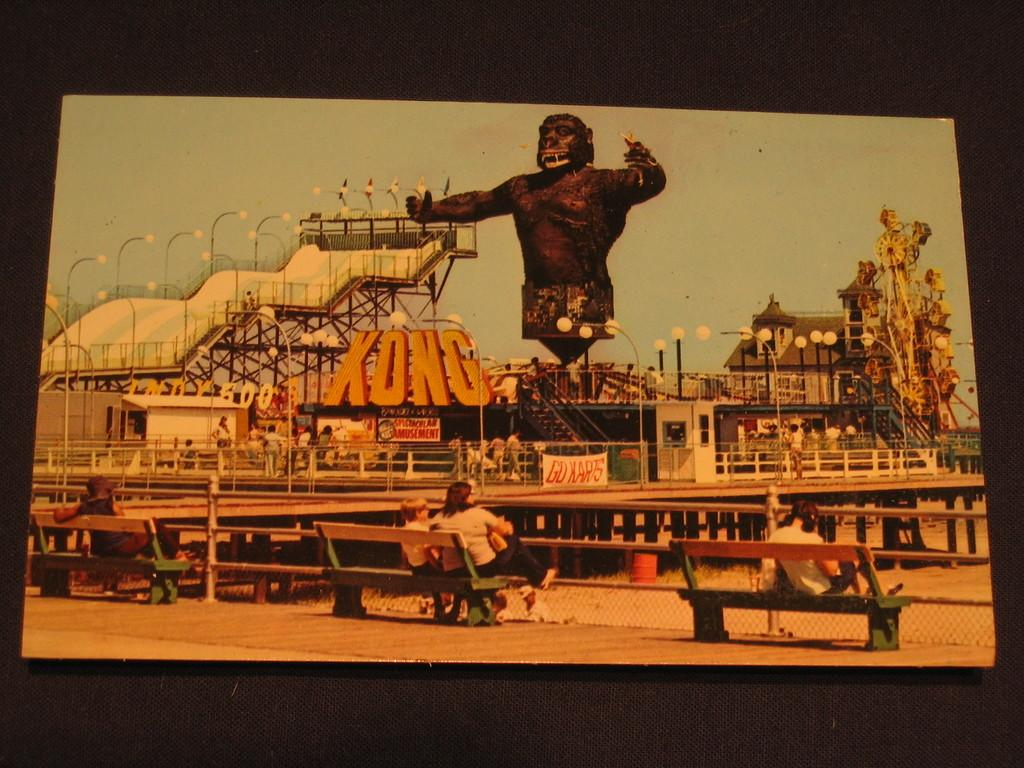<image>
Give a short and clear explanation of the subsequent image. An amusement park ride that has Kong written in large yellow letters. 